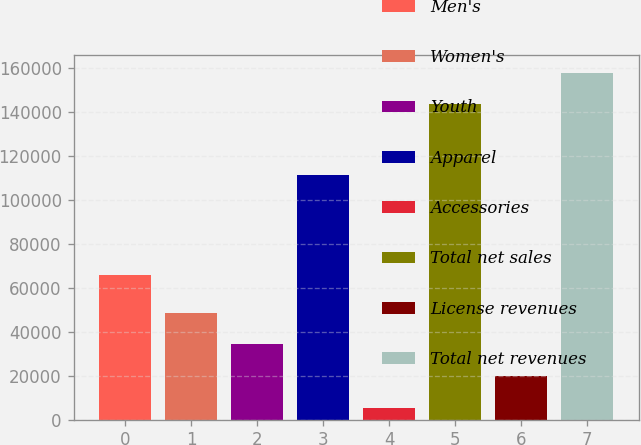<chart> <loc_0><loc_0><loc_500><loc_500><bar_chart><fcel>Men's<fcel>Women's<fcel>Youth<fcel>Apparel<fcel>Accessories<fcel>Total net sales<fcel>License revenues<fcel>Total net revenues<nl><fcel>66085<fcel>48732.4<fcel>34317.6<fcel>111341<fcel>5488<fcel>143703<fcel>19902.8<fcel>158118<nl></chart> 